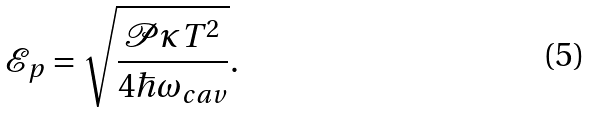<formula> <loc_0><loc_0><loc_500><loc_500>\mathcal { E } _ { p } = \sqrt { \frac { \mathcal { P } \kappa T ^ { 2 } } { 4 \hbar { \omega } _ { c a v } } } .</formula> 